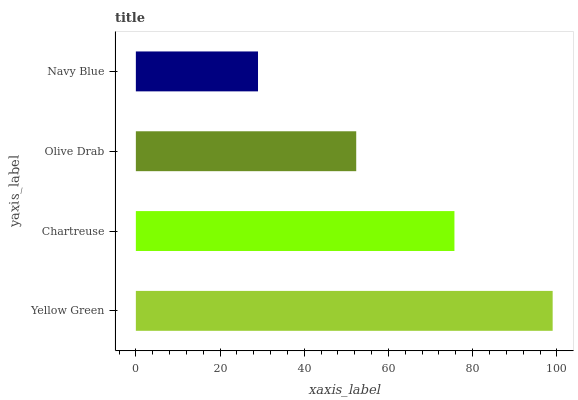Is Navy Blue the minimum?
Answer yes or no. Yes. Is Yellow Green the maximum?
Answer yes or no. Yes. Is Chartreuse the minimum?
Answer yes or no. No. Is Chartreuse the maximum?
Answer yes or no. No. Is Yellow Green greater than Chartreuse?
Answer yes or no. Yes. Is Chartreuse less than Yellow Green?
Answer yes or no. Yes. Is Chartreuse greater than Yellow Green?
Answer yes or no. No. Is Yellow Green less than Chartreuse?
Answer yes or no. No. Is Chartreuse the high median?
Answer yes or no. Yes. Is Olive Drab the low median?
Answer yes or no. Yes. Is Yellow Green the high median?
Answer yes or no. No. Is Yellow Green the low median?
Answer yes or no. No. 